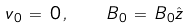Convert formula to latex. <formula><loc_0><loc_0><loc_500><loc_500>v _ { 0 } \, = \, { 0 } \, , \quad B _ { 0 } \, = \, B _ { 0 } \hat { z }</formula> 